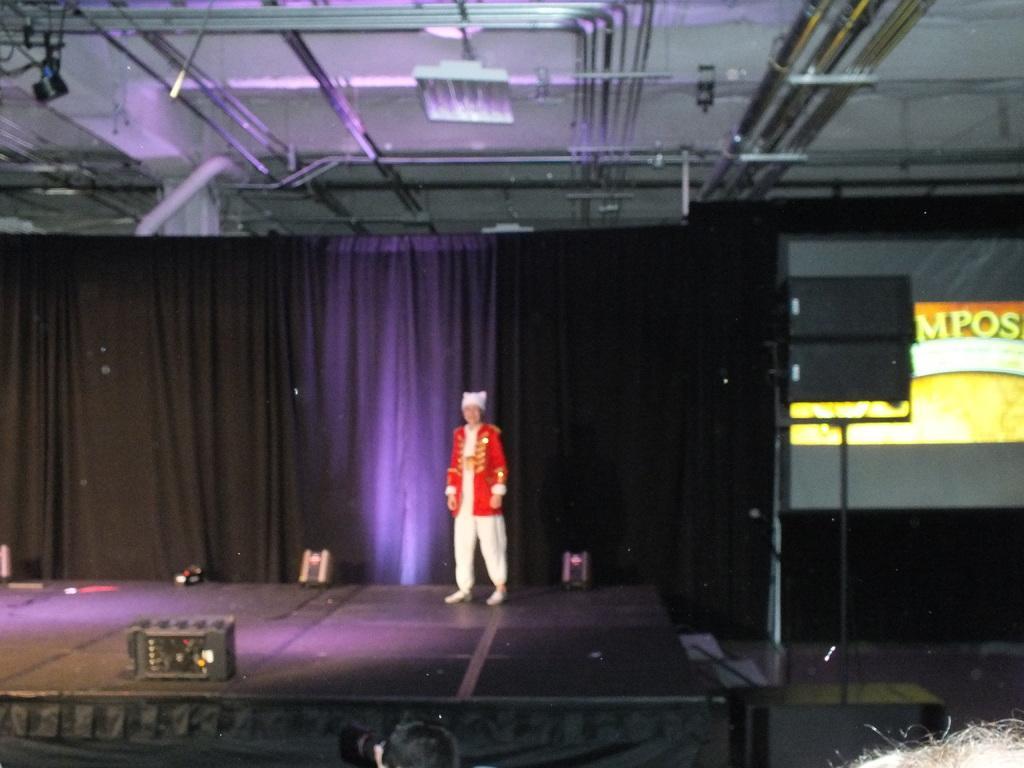Could you give a brief overview of what you see in this image? In this image there is a man standing on the dais. There are lights and a box on the dais. Behind him there is a curtain on the wall. To the right there is a stand. Behind the stand there is a banner on the wall. At the top there are rods and lights to the ceiling. 